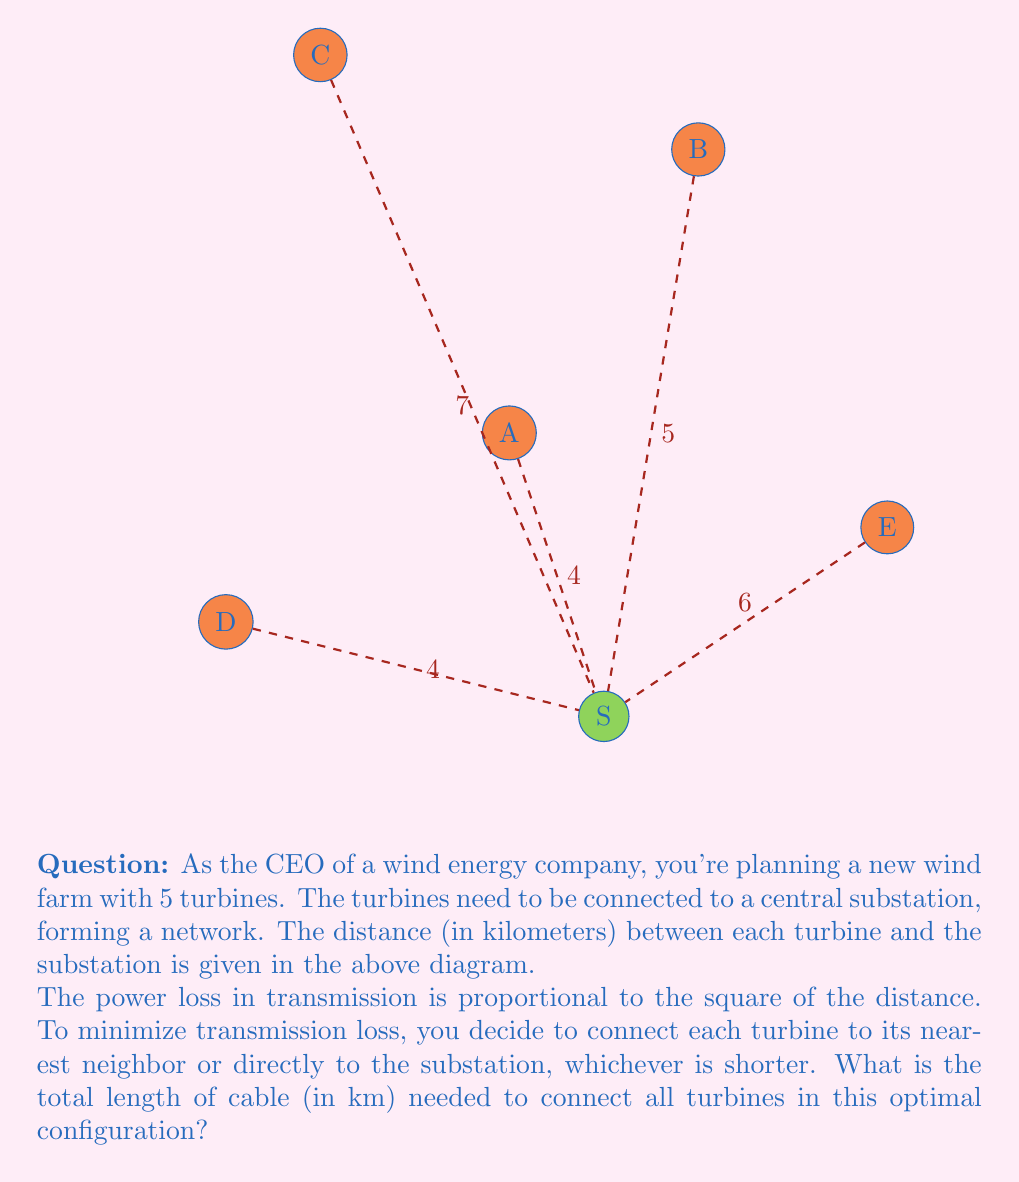Could you help me with this problem? Let's approach this step-by-step:

1) First, we need to calculate the distances between each turbine:
   AB ≈ 3.61 km, AC ≈ 4.47 km, AD ≈ 5.00 km, AE ≈ 4.12 km
   BC ≈ 4.47 km, BD ≈ 6.40 km, BE ≈ 2.83 km
   CD ≈ 6.32 km, CE ≈ 7.21 km
   DE ≈ 7.07 km

2) Now, for each turbine, we compare the distance to its nearest neighbor with the distance to the substation:

   A: Nearest neighbor is B (3.61 km), but substation is closer (4 km)
   B: Nearest neighbor is E (2.83 km), which is closer than substation (5 km)
   C: Substation (7 km) is closer than nearest neighbor A or B (both 4.47 km)
   D: Substation (4 km) is closer than nearest neighbor A (5 km)
   E: Connected to B (2.83 km), which is closer than substation (6 km)

3) The optimal configuration is:
   - A connects directly to S: 4 km
   - B connects to E: 2.83 km
   - C connects directly to S: 7 km
   - D connects directly to S: 4 km
   - E is already connected through B

4) Total cable length:
   $$4 + 2.83 + 7 + 4 = 17.83$$ km

Therefore, the total length of cable needed is 17.83 km.
Answer: 17.83 km 